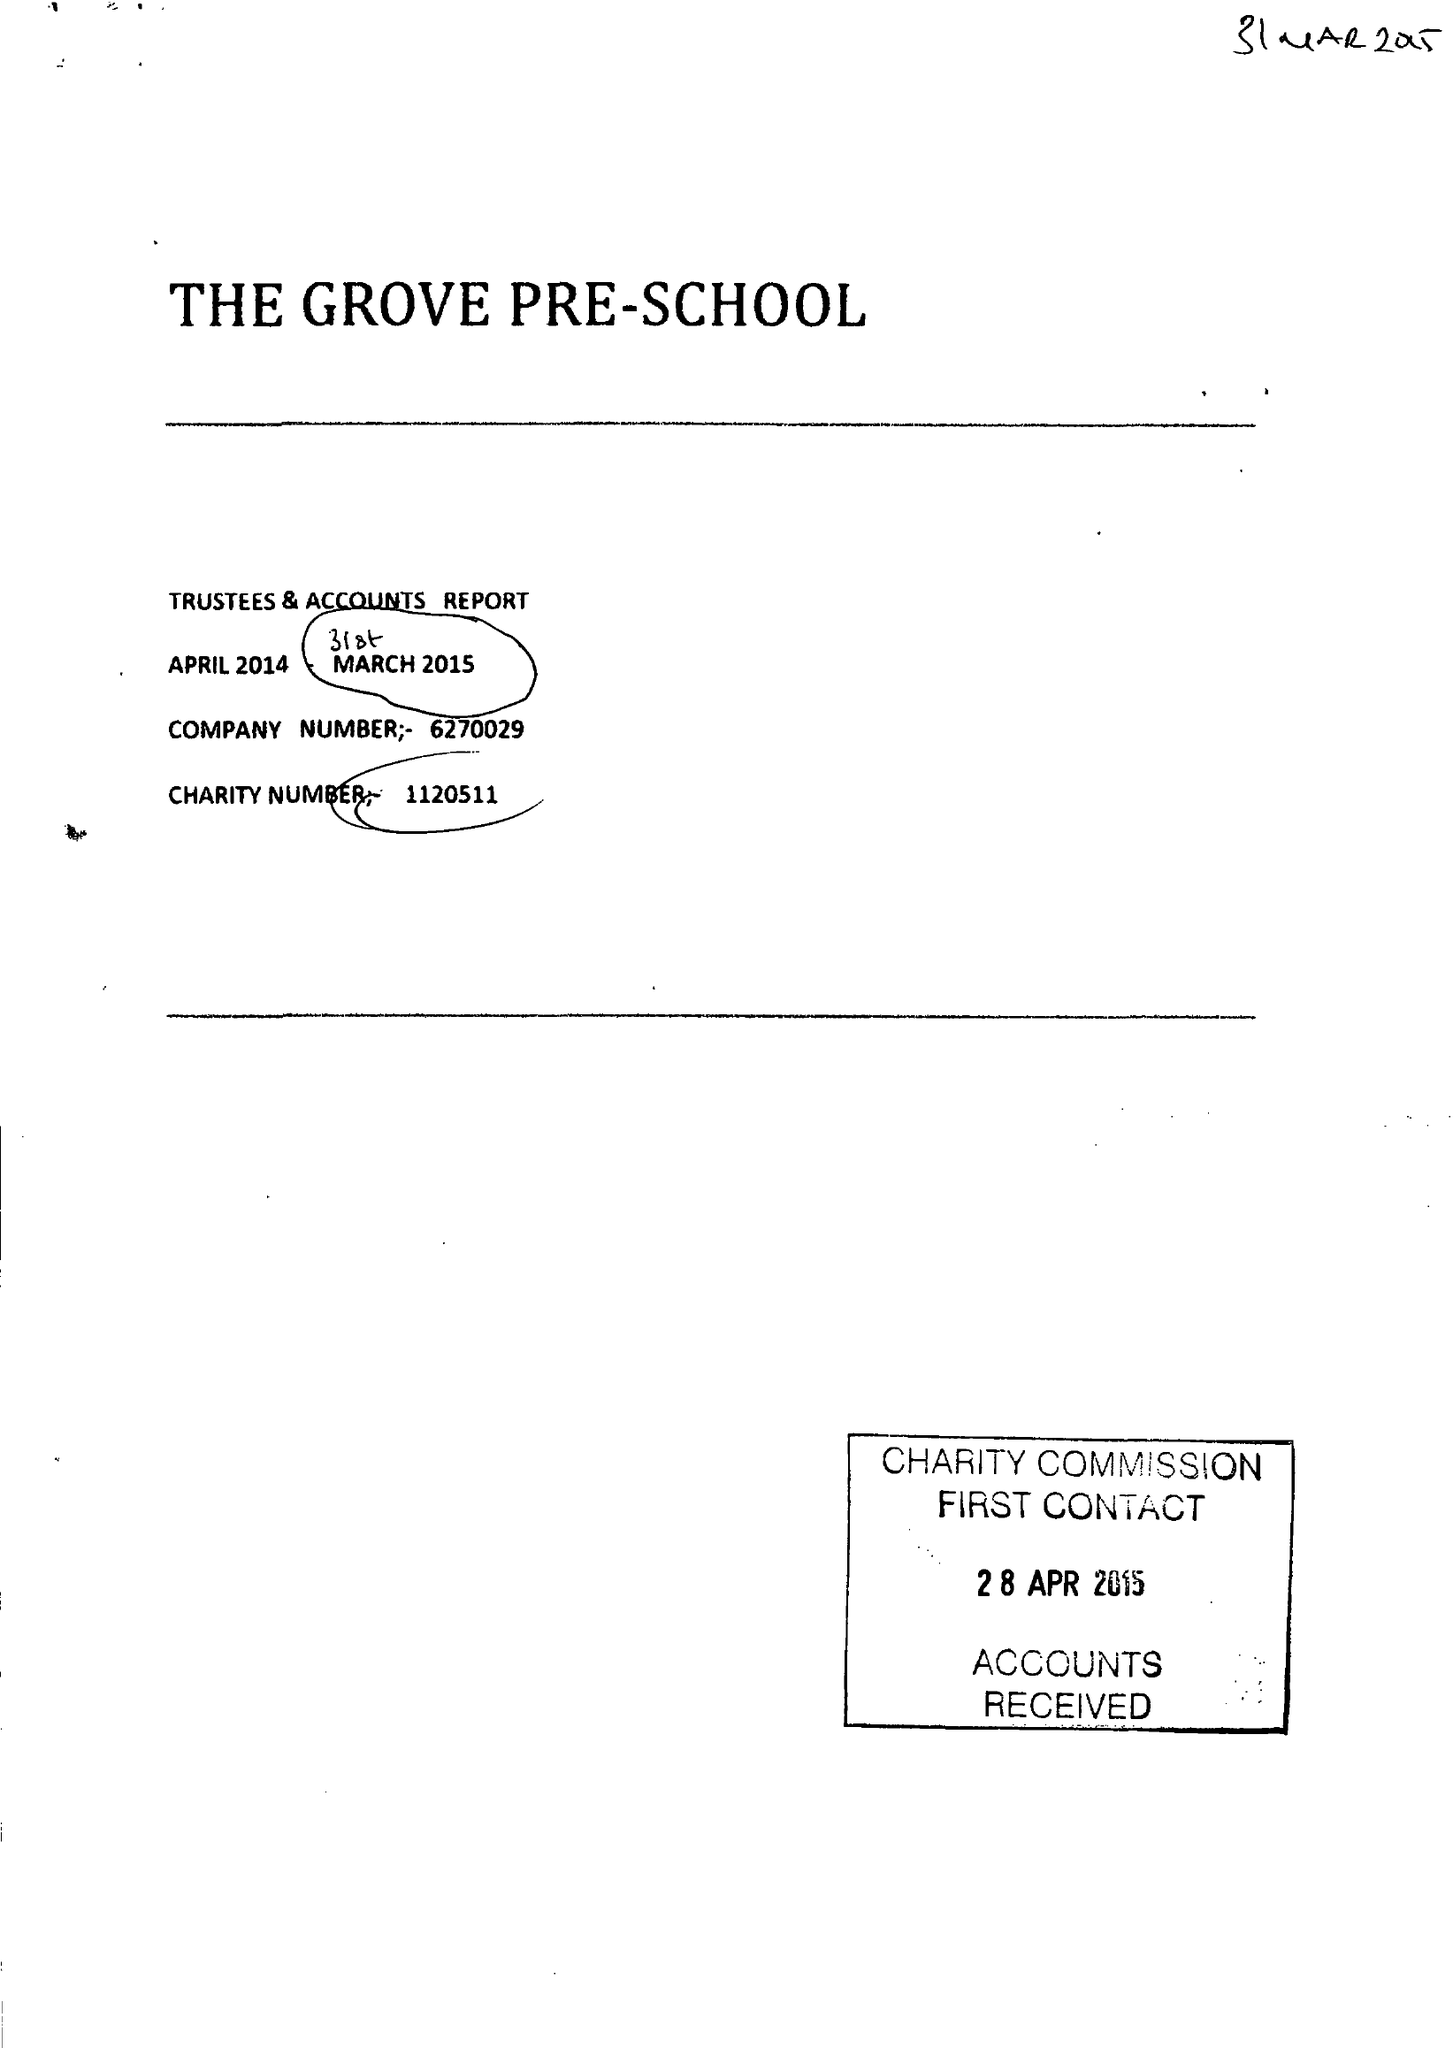What is the value for the income_annually_in_british_pounds?
Answer the question using a single word or phrase. 63674.00 